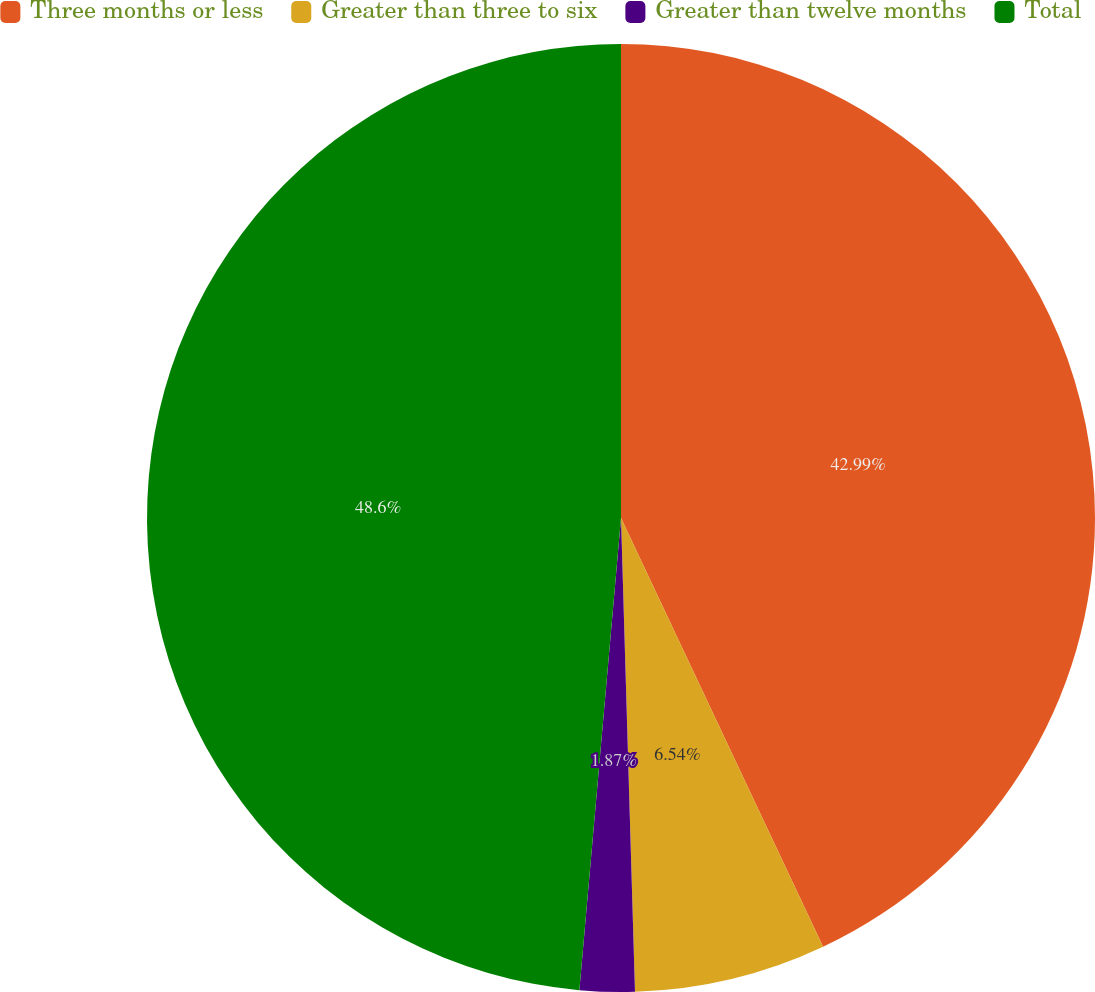Convert chart. <chart><loc_0><loc_0><loc_500><loc_500><pie_chart><fcel>Three months or less<fcel>Greater than three to six<fcel>Greater than twelve months<fcel>Total<nl><fcel>42.99%<fcel>6.54%<fcel>1.87%<fcel>48.6%<nl></chart> 